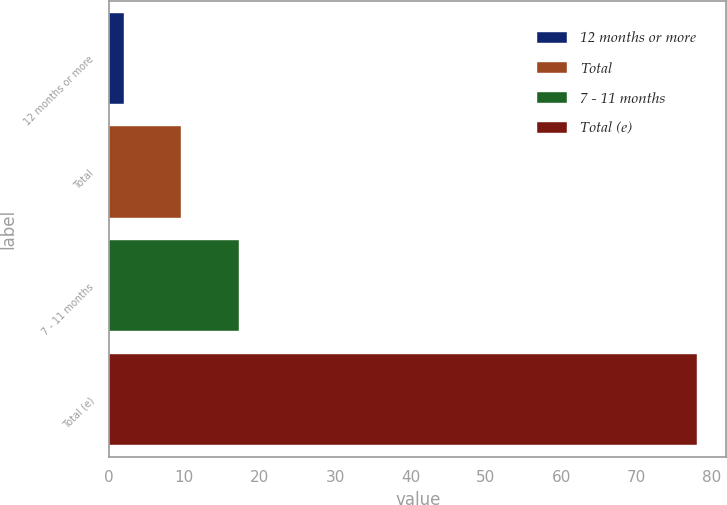Convert chart. <chart><loc_0><loc_0><loc_500><loc_500><bar_chart><fcel>12 months or more<fcel>Total<fcel>7 - 11 months<fcel>Total (e)<nl><fcel>2<fcel>9.6<fcel>17.2<fcel>78<nl></chart> 